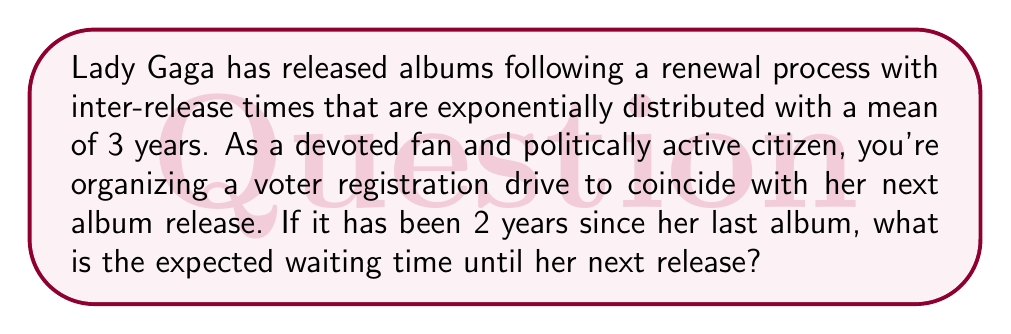Can you solve this math problem? Let's approach this step-by-step using renewal process theory:

1) In a renewal process with exponentially distributed inter-arrival times, the process has the memoryless property. This means that regardless of how long it's been since the last event, the expected time until the next event remains constant.

2) For an exponential distribution with mean $\mu$, the probability density function is:

   $$f(t) = \frac{1}{\mu}e^{-t/\mu}$$

3) The expected value (mean) of this distribution is $\mu$. In this case, $\mu = 3$ years.

4) Due to the memoryless property, the fact that it has been 2 years since the last album release doesn't affect the expected waiting time for the next release.

5) Therefore, the expected waiting time from now until the next album release is still the mean of the exponential distribution, which is 3 years.

This result aligns with the renewal theory concept of the "residual life" or "excess life" in a renewal process with exponentially distributed inter-arrival times.
Answer: 3 years 